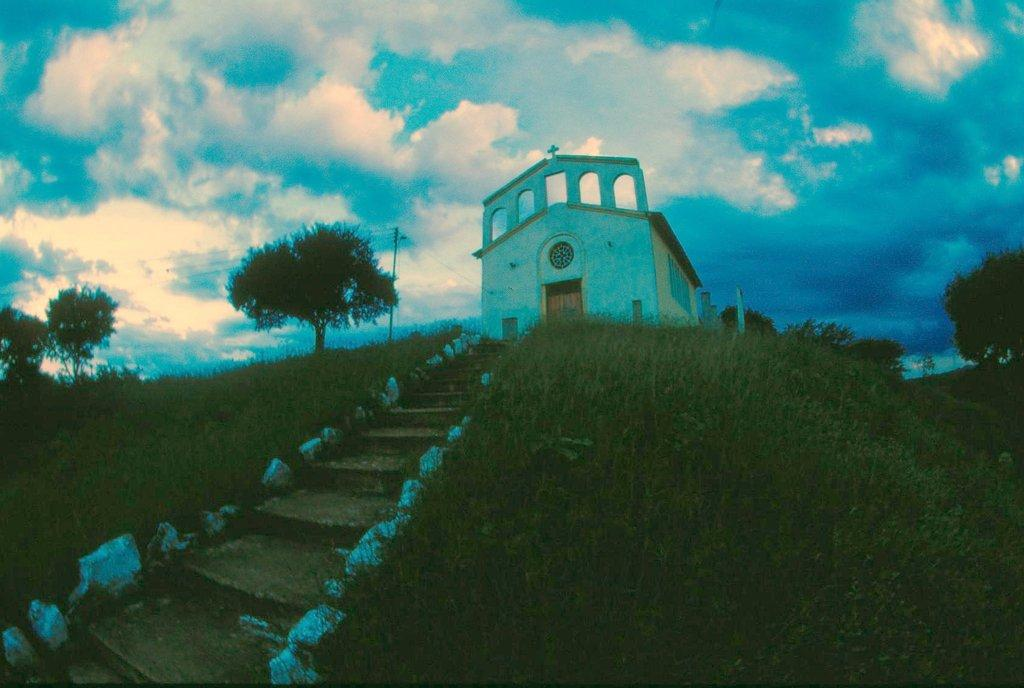What is visible in the foreground of the picture? In the foreground of the picture, there is grass, a staircase, a church, trees, a pole, and cables. Can you describe the church in the foreground? The church in the foreground is a prominent structure with architectural details. What is the weather like in the picture? The sky is cloudy, indicating that the weather might be overcast or partly cloudy. At what time of day was the picture taken? The picture was taken during sunset, as indicated by the warm colors and the position of the sun. How many girls are playing with the thunder in the picture? There are no girls or thunder present in the image. What type of cloud is depicted in the picture? The provided facts do not mention any specific type of cloud; the sky is simply described as cloudy. 